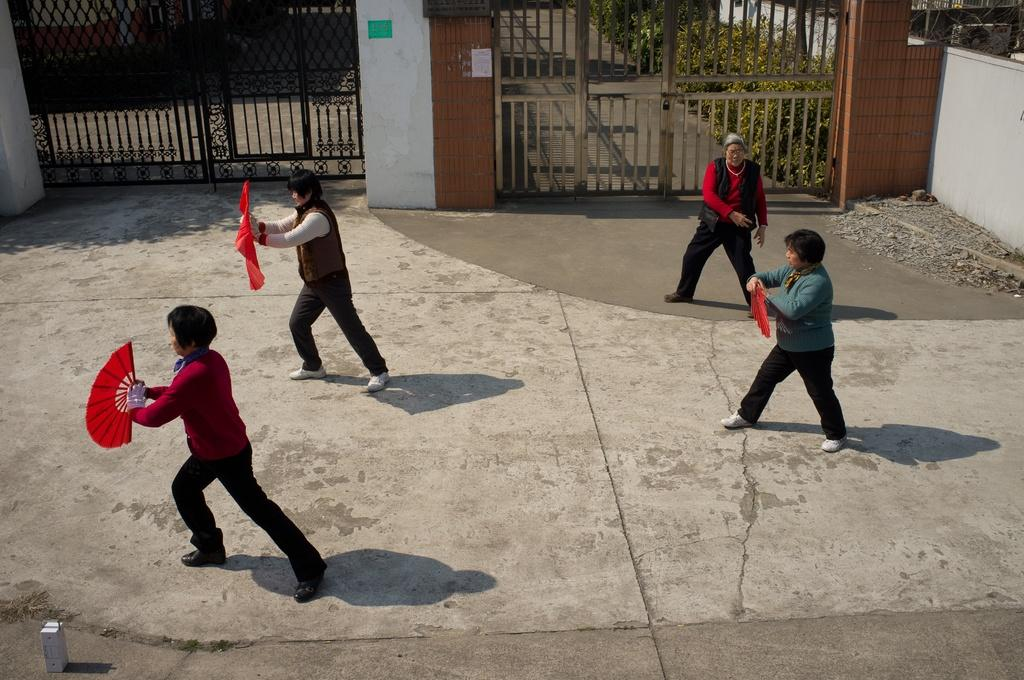How many people are standing in the image? There are four people standing in the image. What are three of the people holding? Three people are holding hand fans. Can you describe the architectural feature in the image? There are 2 gates in the image. What type of vegetation is visible in the background? There are plants at the back in the image. What is the price of the silver wing on the left side of the image? There is no silver wing present in the image. What type of silver object is visible in the image? There is no silver object present in the image. 